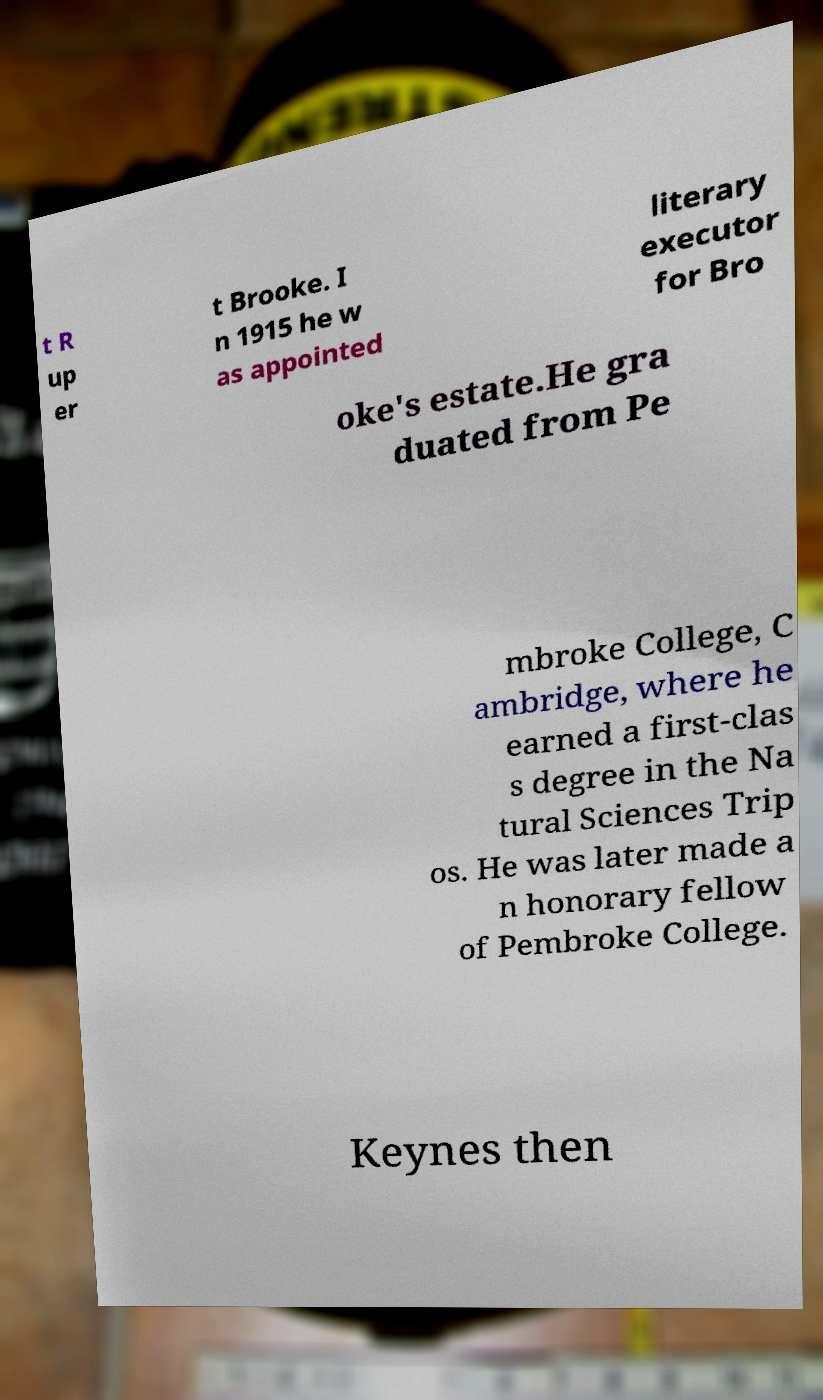Could you assist in decoding the text presented in this image and type it out clearly? t R up er t Brooke. I n 1915 he w as appointed literary executor for Bro oke's estate.He gra duated from Pe mbroke College, C ambridge, where he earned a first-clas s degree in the Na tural Sciences Trip os. He was later made a n honorary fellow of Pembroke College. Keynes then 